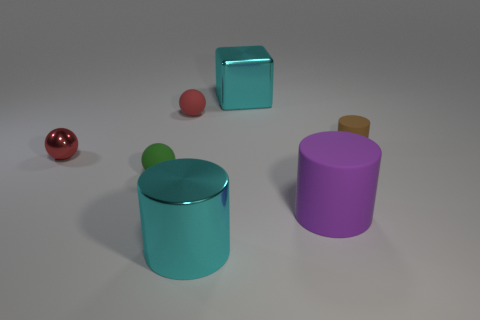Subtract all cyan shiny cylinders. How many cylinders are left? 2 Add 2 tiny red objects. How many objects exist? 9 Subtract all green spheres. How many spheres are left? 2 Subtract 2 spheres. How many spheres are left? 1 Subtract all green cubes. Subtract all blue balls. How many cubes are left? 1 Subtract all purple spheres. How many purple cylinders are left? 1 Subtract all green rubber objects. Subtract all cyan metallic cubes. How many objects are left? 5 Add 6 brown matte things. How many brown matte things are left? 7 Add 4 large brown cubes. How many large brown cubes exist? 4 Subtract 0 yellow blocks. How many objects are left? 7 